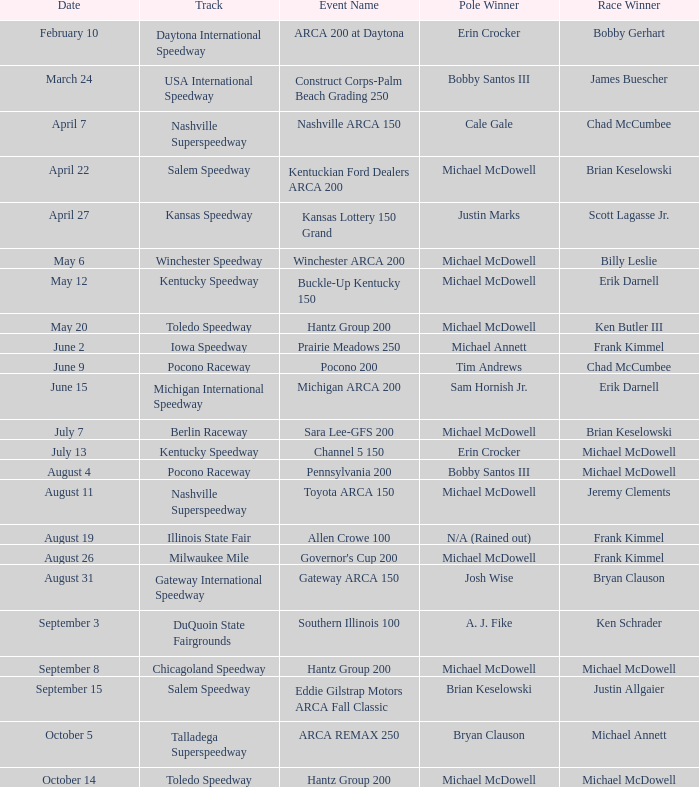Parse the full table. {'header': ['Date', 'Track', 'Event Name', 'Pole Winner', 'Race Winner'], 'rows': [['February 10', 'Daytona International Speedway', 'ARCA 200 at Daytona', 'Erin Crocker', 'Bobby Gerhart'], ['March 24', 'USA International Speedway', 'Construct Corps-Palm Beach Grading 250', 'Bobby Santos III', 'James Buescher'], ['April 7', 'Nashville Superspeedway', 'Nashville ARCA 150', 'Cale Gale', 'Chad McCumbee'], ['April 22', 'Salem Speedway', 'Kentuckian Ford Dealers ARCA 200', 'Michael McDowell', 'Brian Keselowski'], ['April 27', 'Kansas Speedway', 'Kansas Lottery 150 Grand', 'Justin Marks', 'Scott Lagasse Jr.'], ['May 6', 'Winchester Speedway', 'Winchester ARCA 200', 'Michael McDowell', 'Billy Leslie'], ['May 12', 'Kentucky Speedway', 'Buckle-Up Kentucky 150', 'Michael McDowell', 'Erik Darnell'], ['May 20', 'Toledo Speedway', 'Hantz Group 200', 'Michael McDowell', 'Ken Butler III'], ['June 2', 'Iowa Speedway', 'Prairie Meadows 250', 'Michael Annett', 'Frank Kimmel'], ['June 9', 'Pocono Raceway', 'Pocono 200', 'Tim Andrews', 'Chad McCumbee'], ['June 15', 'Michigan International Speedway', 'Michigan ARCA 200', 'Sam Hornish Jr.', 'Erik Darnell'], ['July 7', 'Berlin Raceway', 'Sara Lee-GFS 200', 'Michael McDowell', 'Brian Keselowski'], ['July 13', 'Kentucky Speedway', 'Channel 5 150', 'Erin Crocker', 'Michael McDowell'], ['August 4', 'Pocono Raceway', 'Pennsylvania 200', 'Bobby Santos III', 'Michael McDowell'], ['August 11', 'Nashville Superspeedway', 'Toyota ARCA 150', 'Michael McDowell', 'Jeremy Clements'], ['August 19', 'Illinois State Fair', 'Allen Crowe 100', 'N/A (Rained out)', 'Frank Kimmel'], ['August 26', 'Milwaukee Mile', "Governor's Cup 200", 'Michael McDowell', 'Frank Kimmel'], ['August 31', 'Gateway International Speedway', 'Gateway ARCA 150', 'Josh Wise', 'Bryan Clauson'], ['September 3', 'DuQuoin State Fairgrounds', 'Southern Illinois 100', 'A. J. Fike', 'Ken Schrader'], ['September 8', 'Chicagoland Speedway', 'Hantz Group 200', 'Michael McDowell', 'Michael McDowell'], ['September 15', 'Salem Speedway', 'Eddie Gilstrap Motors ARCA Fall Classic', 'Brian Keselowski', 'Justin Allgaier'], ['October 5', 'Talladega Superspeedway', 'ARCA REMAX 250', 'Bryan Clauson', 'Michael Annett'], ['October 14', 'Toledo Speedway', 'Hantz Group 200', 'Michael McDowell', 'Michael McDowell']]} Tell me the event name for michael mcdowell and billy leslie Winchester ARCA 200. 